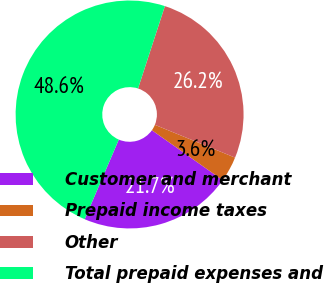<chart> <loc_0><loc_0><loc_500><loc_500><pie_chart><fcel>Customer and merchant<fcel>Prepaid income taxes<fcel>Other<fcel>Total prepaid expenses and<nl><fcel>21.67%<fcel>3.6%<fcel>26.17%<fcel>48.57%<nl></chart> 